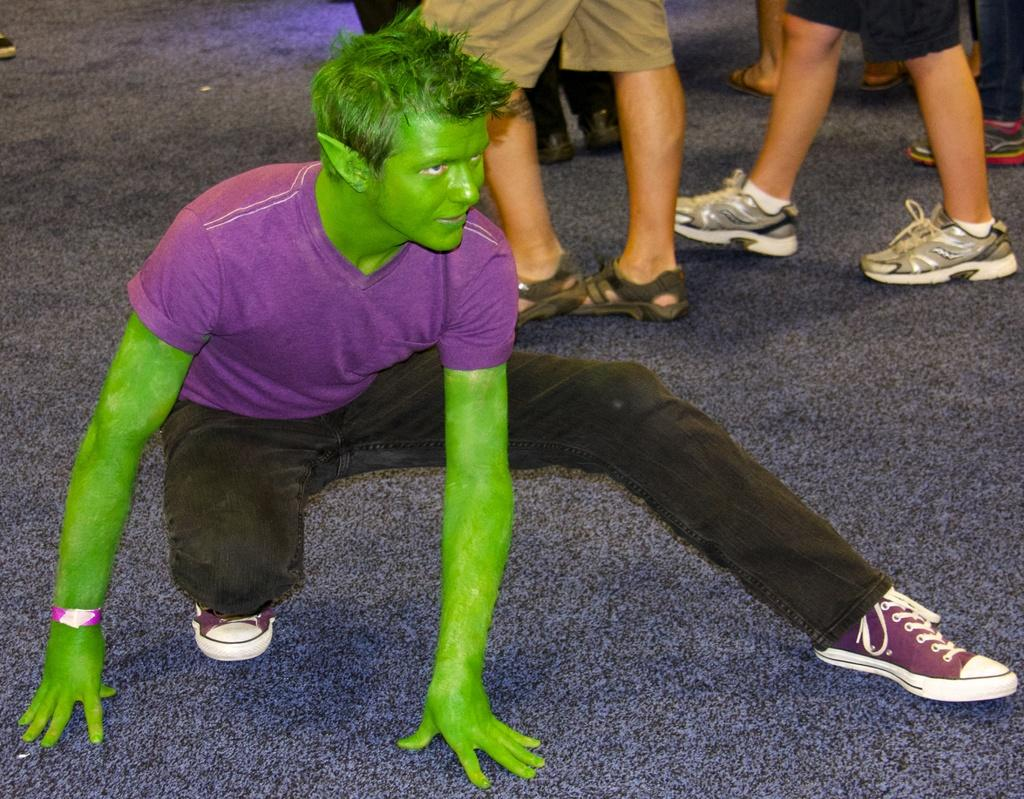What is present in the image? There are people in the image. Can you describe the actions of the people in the image? In the background of the image, there are people walking. What type of rail can be seen in the image? There is no rail present in the image. How many men are visible in the image? The number of men cannot be determined from the provided facts, as the image only mentions "people" without specifying their gender. 